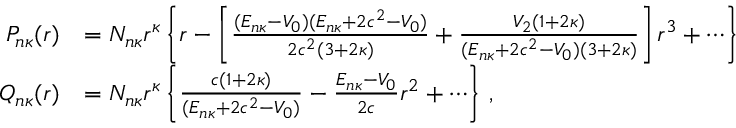<formula> <loc_0><loc_0><loc_500><loc_500>\begin{array} { r } { \begin{array} { r l } { P _ { n \kappa } ( r ) } & { = N _ { n \kappa } r ^ { \kappa } \left \{ r - \left [ \frac { ( E _ { n \kappa } - V _ { 0 } ) ( E _ { n \kappa } + 2 c ^ { 2 } - V _ { 0 } ) } { 2 c ^ { 2 } ( 3 + 2 \kappa ) } + \frac { V _ { 2 } ( 1 + 2 \kappa ) } { ( E _ { n \kappa } + 2 c ^ { 2 } - V _ { 0 } ) ( 3 + 2 \kappa ) } \right ] r ^ { 3 } + \cdots \right \} } \\ { Q _ { n \kappa } ( r ) } & { = N _ { n \kappa } r ^ { \kappa } \left \{ \frac { c ( 1 + 2 \kappa ) } { ( E _ { n \kappa } + 2 c ^ { 2 } - V _ { 0 } ) } - \frac { E _ { n \kappa } - V _ { 0 } } { 2 c } r ^ { 2 } + \cdots \right \} \, , } \end{array} } \end{array}</formula> 